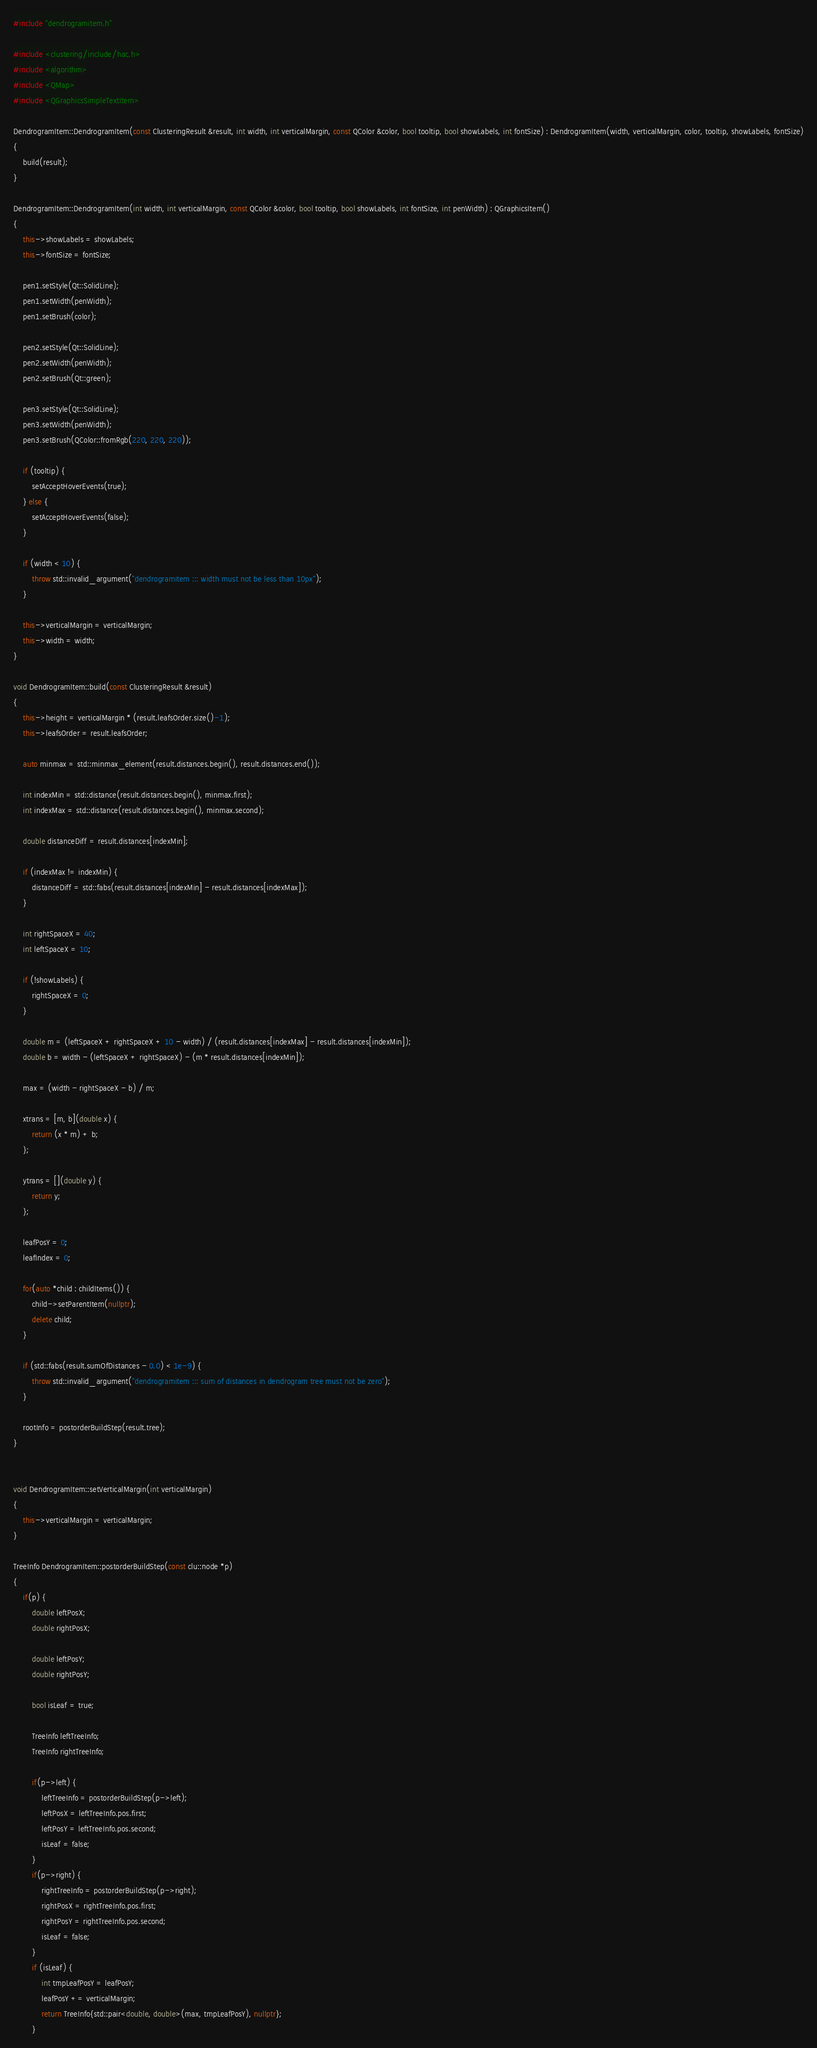Convert code to text. <code><loc_0><loc_0><loc_500><loc_500><_C++_>#include "dendrogramitem.h"

#include <clustering/include/hac.h>
#include <algorithm>
#include <QMap>
#include <QGraphicsSimpleTextItem>

DendrogramItem::DendrogramItem(const ClusteringResult &result, int width, int verticalMargin, const QColor &color, bool tooltip, bool showLabels, int fontSize) : DendrogramItem(width, verticalMargin, color, tooltip, showLabels, fontSize)
{
    build(result);
}

DendrogramItem::DendrogramItem(int width, int verticalMargin, const QColor &color, bool tooltip, bool showLabels, int fontSize, int penWidth) : QGraphicsItem()
{
    this->showLabels = showLabels;
    this->fontSize = fontSize;

    pen1.setStyle(Qt::SolidLine);
    pen1.setWidth(penWidth);
    pen1.setBrush(color);

    pen2.setStyle(Qt::SolidLine);
    pen2.setWidth(penWidth);
    pen2.setBrush(Qt::green);

    pen3.setStyle(Qt::SolidLine);
    pen3.setWidth(penWidth);
    pen3.setBrush(QColor::fromRgb(220, 220, 220));

    if (tooltip) {
        setAcceptHoverEvents(true);
    } else {
        setAcceptHoverEvents(false);
    }

    if (width < 10) {
        throw std::invalid_argument("dendrogramitem ::: width must not be less than 10px");
    }

    this->verticalMargin = verticalMargin;
    this->width = width;
}

void DendrogramItem::build(const ClusteringResult &result)
{
    this->height = verticalMargin * (result.leafsOrder.size()-1);
    this->leafsOrder = result.leafsOrder;

    auto minmax = std::minmax_element(result.distances.begin(), result.distances.end());

    int indexMin = std::distance(result.distances.begin(), minmax.first);
    int indexMax = std::distance(result.distances.begin(), minmax.second);

    double distanceDiff = result.distances[indexMin];

    if (indexMax != indexMin) {
        distanceDiff = std::fabs(result.distances[indexMin] - result.distances[indexMax]);
    }

    int rightSpaceX = 40;
    int leftSpaceX = 10;

    if (!showLabels) {
        rightSpaceX = 0;
    }

    double m = (leftSpaceX + rightSpaceX + 10 - width) / (result.distances[indexMax] - result.distances[indexMin]);
    double b = width - (leftSpaceX + rightSpaceX) - (m * result.distances[indexMin]);

    max = (width - rightSpaceX - b) / m;

    xtrans = [m, b](double x) {
        return (x * m) + b;
    };

    ytrans = [](double y) {
        return y;
    };

    leafPosY = 0;
    leafIndex = 0;

    for(auto *child : childItems()) {
        child->setParentItem(nullptr);
        delete child;
    }

    if (std::fabs(result.sumOfDistances - 0.0) < 1e-9) {
        throw std::invalid_argument("dendrogramitem ::: sum of distances in dendrogram tree must not be zero");
    }

    rootInfo = postorderBuildStep(result.tree);
}


void DendrogramItem::setVerticalMargin(int verticalMargin)
{
    this->verticalMargin = verticalMargin;
}

TreeInfo DendrogramItem::postorderBuildStep(const clu::node *p)
{
    if(p) {
        double leftPosX;
        double rightPosX;

        double leftPosY;
        double rightPosY;

        bool isLeaf = true;

        TreeInfo leftTreeInfo;
        TreeInfo rightTreeInfo;

        if(p->left) {
            leftTreeInfo = postorderBuildStep(p->left);
            leftPosX = leftTreeInfo.pos.first;
            leftPosY = leftTreeInfo.pos.second;
            isLeaf = false;
        }
        if(p->right) {
            rightTreeInfo = postorderBuildStep(p->right);
            rightPosX = rightTreeInfo.pos.first;
            rightPosY = rightTreeInfo.pos.second;
            isLeaf = false;
        }
        if (isLeaf) {
            int tmpLeafPosY = leafPosY;
            leafPosY += verticalMargin;
            return TreeInfo{std::pair<double, double>(max, tmpLeafPosY), nullptr};
        }
</code> 